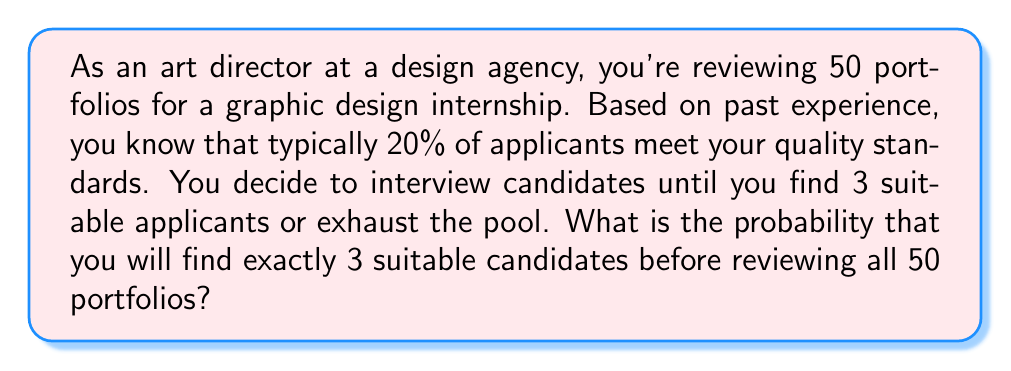Show me your answer to this math problem. To solve this problem, we can use the negative binomial distribution. This distribution models the number of failures before a specified number of successes occurs in a sequence of independent trials.

Let's define our parameters:
- $p$ = probability of success (finding a suitable candidate) = 0.20
- $q$ = probability of failure (not finding a suitable candidate) = 1 - p = 0.80
- $r$ = number of successes we want = 3
- $n$ = number of trials before the 3rd success
- $N$ = total number of portfolios = 50

We want to find the probability of getting exactly 3 successes before reviewing all 50 portfolios. This means we need to sum the probabilities of finding the 3rd success on the 3rd, 4th, 5th, ..., up to the 49th trial.

The probability mass function for the negative binomial distribution is:

$$ P(X = n) = \binom{n+r-1}{r-1} p^r q^n $$

Where $n$ is the number of failures before the $r$th success.

We need to sum this probability for $n = 0$ to $n = 46$ (as $n + r = 49$, the last possible trial):

$$ P(\text{3 successes before 50th trial}) = \sum_{n=0}^{46} \binom{n+2}{2} (0.2)^3 (0.8)^n $$

This sum can be calculated using a computer or calculator:

$$ \approx 0.8792 $$
Answer: The probability of finding exactly 3 suitable candidates before reviewing all 50 portfolios is approximately 0.8792 or 87.92%. 